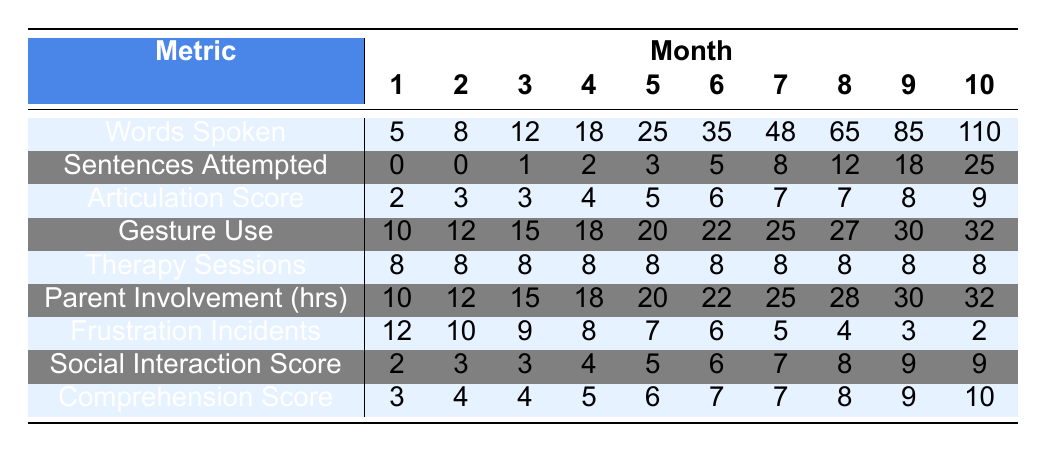What is the number of words spoken in month 10? The table shows the value in the "Words Spoken" row for month 10, which is 110.
Answer: 110 How many sentences were attempted in month 5? By looking at the "Sentences Attempted" row for month 5, the value is 3.
Answer: 3 What was the articulation score in month 7? The "Articulation Score" for month 7 is listed in that row as 7.
Answer: 7 How many words were spoken in month 1 compared to month 3? In month 1, 5 words were spoken and in month 3, 12 words were spoken. The difference is 12 - 5 = 7.
Answer: 7 What is the total number of therapy sessions over the 10 months? Therapy sessions are consistently 8 for each of the 10 months, so 8 sessions/month * 10 months = 80 total sessions.
Answer: 80 What was the highest frustration incidents recorded? The "Frustration Incidents" row shows the highest value is 12, recorded in month 1.
Answer: 12 How many more parent involvement hours were there in month 10 than in month 1? In month 1, there were 10 hours and in month 10, there were 32 hours. The difference is 32 - 10 = 22 hours.
Answer: 22 What is the average comprehension score across all months? The comprehension scores are 3, 4, 4, 5, 6, 7, 7, 8, 9, 10. The average is (3 + 4 + 4 + 5 + 6 + 7 + 7 + 8 + 9 + 10)/10 = 5.7.
Answer: 5.7 In which month did the social interaction score first reach 7? The social interaction score reaches 7 in month 7, as indicated in the "Social Interaction Score" row.
Answer: Month 7 By month 9, what is the total count of sentences attempted? The total count of sentences attempted by month 9 is found by adding values from month 1 to month 9: 0 + 0 + 1 + 2 + 3 + 5 + 8 + 12 + 18 = 49.
Answer: 49 